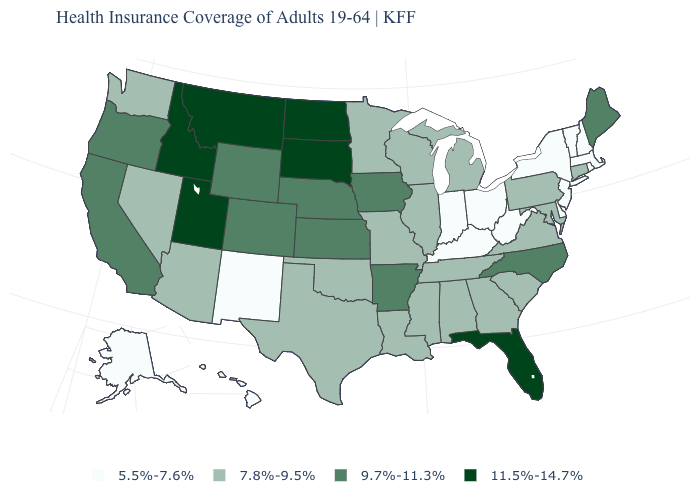Which states have the lowest value in the USA?
Quick response, please. Alaska, Delaware, Hawaii, Indiana, Kentucky, Massachusetts, New Hampshire, New Jersey, New Mexico, New York, Ohio, Rhode Island, Vermont, West Virginia. What is the value of Massachusetts?
Write a very short answer. 5.5%-7.6%. What is the value of Rhode Island?
Write a very short answer. 5.5%-7.6%. Does Maine have the highest value in the Northeast?
Quick response, please. Yes. Does Utah have the highest value in the USA?
Give a very brief answer. Yes. Among the states that border Maryland , which have the highest value?
Keep it brief. Pennsylvania, Virginia. Does Massachusetts have the highest value in the Northeast?
Keep it brief. No. Does Florida have the highest value in the South?
Quick response, please. Yes. What is the highest value in the USA?
Write a very short answer. 11.5%-14.7%. Does Florida have the highest value in the South?
Quick response, please. Yes. Among the states that border Oregon , does California have the lowest value?
Short answer required. No. Does Idaho have a lower value than South Carolina?
Quick response, please. No. Name the states that have a value in the range 9.7%-11.3%?
Give a very brief answer. Arkansas, California, Colorado, Iowa, Kansas, Maine, Nebraska, North Carolina, Oregon, Wyoming. Name the states that have a value in the range 9.7%-11.3%?
Be succinct. Arkansas, California, Colorado, Iowa, Kansas, Maine, Nebraska, North Carolina, Oregon, Wyoming. Name the states that have a value in the range 11.5%-14.7%?
Write a very short answer. Florida, Idaho, Montana, North Dakota, South Dakota, Utah. 